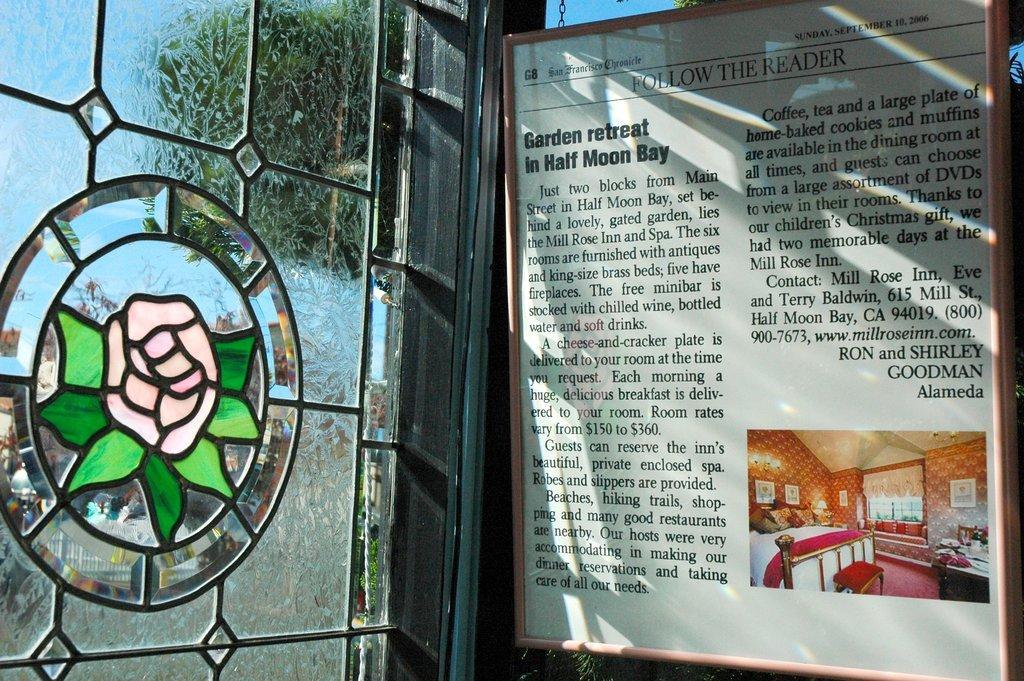Could you give a brief overview of what you see in this image? In this image we can see a board with the text and also the picture. We can also see a window with the flower design. Some part of the sky is also visible in this image. 